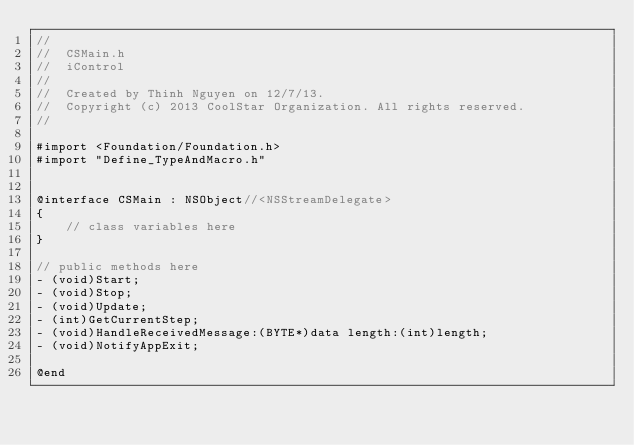<code> <loc_0><loc_0><loc_500><loc_500><_C_>//
//  CSMain.h
//  iControl
//
//  Created by Thinh Nguyen on 12/7/13.
//  Copyright (c) 2013 CoolStar Organization. All rights reserved.
//

#import <Foundation/Foundation.h>
#import "Define_TypeAndMacro.h"


@interface CSMain : NSObject//<NSStreamDelegate>
{
    // class variables here
}

// public methods here
- (void)Start;
- (void)Stop;
- (void)Update;
- (int)GetCurrentStep;
- (void)HandleReceivedMessage:(BYTE*)data length:(int)length;
- (void)NotifyAppExit;

@end


</code> 